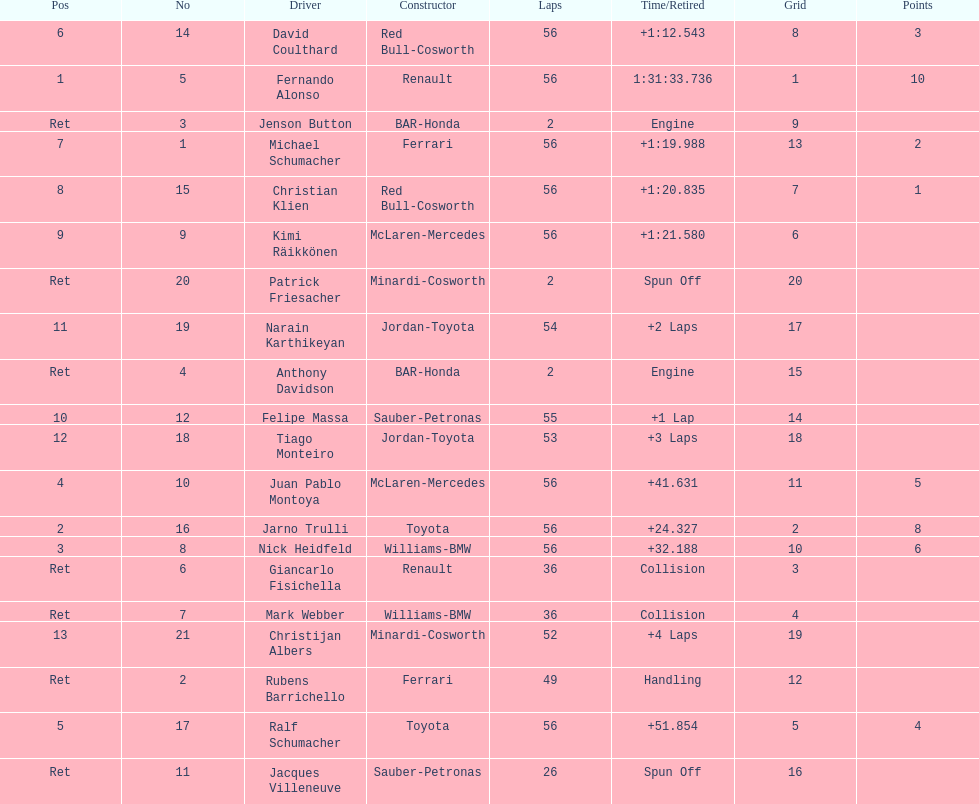What were the total number of laps completed by the 1st position winner? 56. 